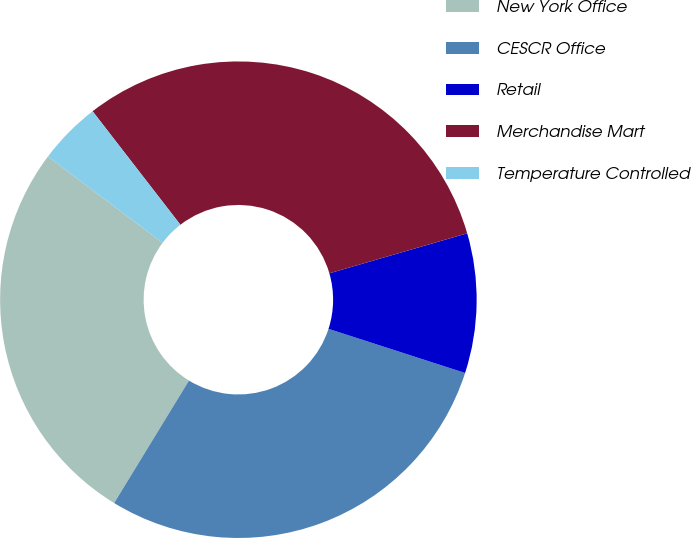Convert chart to OTSL. <chart><loc_0><loc_0><loc_500><loc_500><pie_chart><fcel>New York Office<fcel>CESCR Office<fcel>Retail<fcel>Merchandise Mart<fcel>Temperature Controlled<nl><fcel>26.53%<fcel>28.75%<fcel>9.47%<fcel>30.98%<fcel>4.26%<nl></chart> 